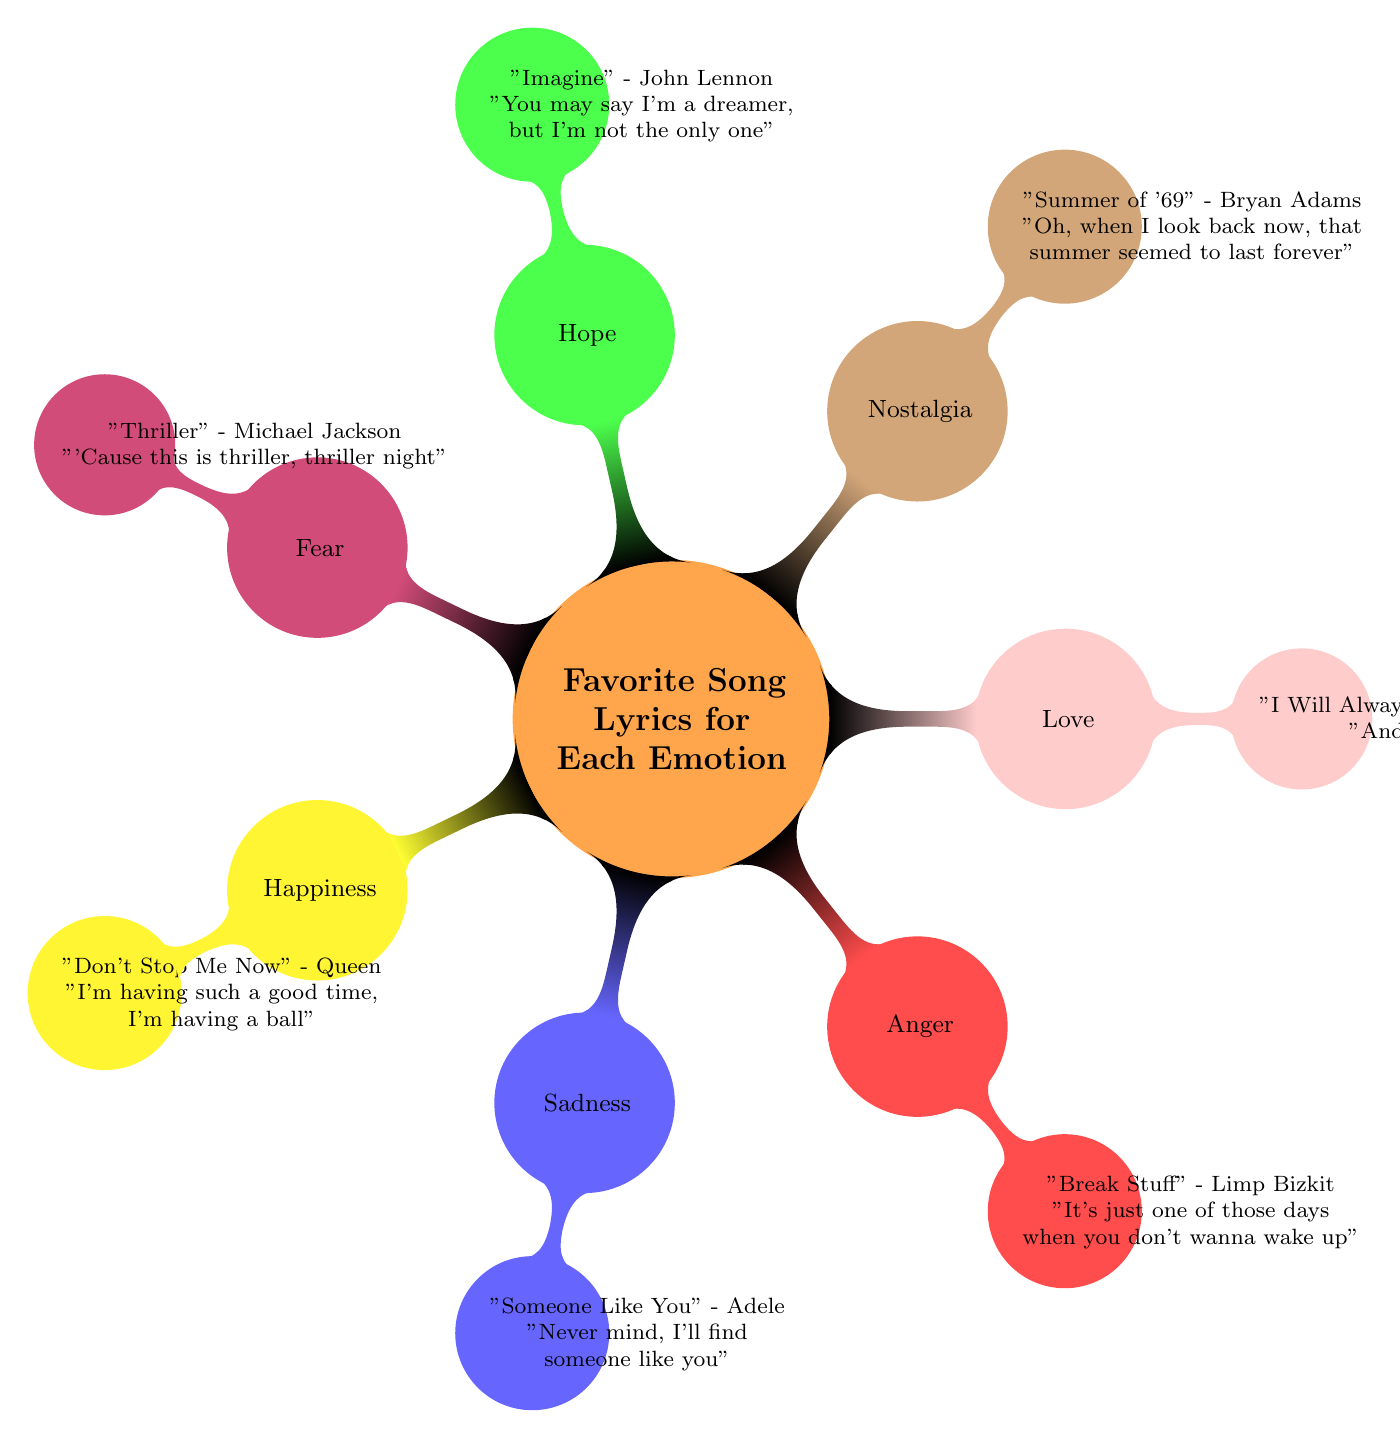What is the song associated with happiness? The node under happiness lists the song "Don't Stop Me Now" by Queen, which represents the emotion of happiness in the diagram.
Answer: "Don't Stop Me Now" How many emotions are represented in the mind map? The main topic lists a total of seven emotions: Happiness, Sadness, Anger, Love, Nostalgia, Hope, and Fear. Therefore, the count of emotions is seven.
Answer: 7 Which artist's lyrics are quoted for the emotion of love? The node under love indicates that the artist quoted is Whitney Houston from the song "I Will Always Love You," representing the emotion of love.
Answer: Whitney Houston What do the lyrics for sadness express? The lyrics quoted under the sadness node are "Never mind, I'll find someone like you," which express a feeling of loss and longing associated with sadness.
Answer: "Never mind, I'll find someone like you" Which emotion is associated with the song "Imagine"? In the diagram, the song "Imagine" is listed under the hope node, indicating that it is associated with the emotion of hope.
Answer: Hope Which node is represented by the color red? In the mind map, the red color denotes the anger node, which highlights the emotional context tied to that color.
Answer: Anger What is the theme of the lyrics for nostalgia? The lyrics quoted under nostalgia are "Oh, when I look back now, that summer seemed to last forever," which convey a sense of longing for the past and memories related to nostalgia.
Answer: Longing for the past Which emotion corresponds to the iconic line "Cause this is thriller, thriller night"? The line from Michael Jackson's song "Thriller" is categorized under the fear node, connecting the iconic lyrics with the emotion of fear in the mind map.
Answer: Fear 